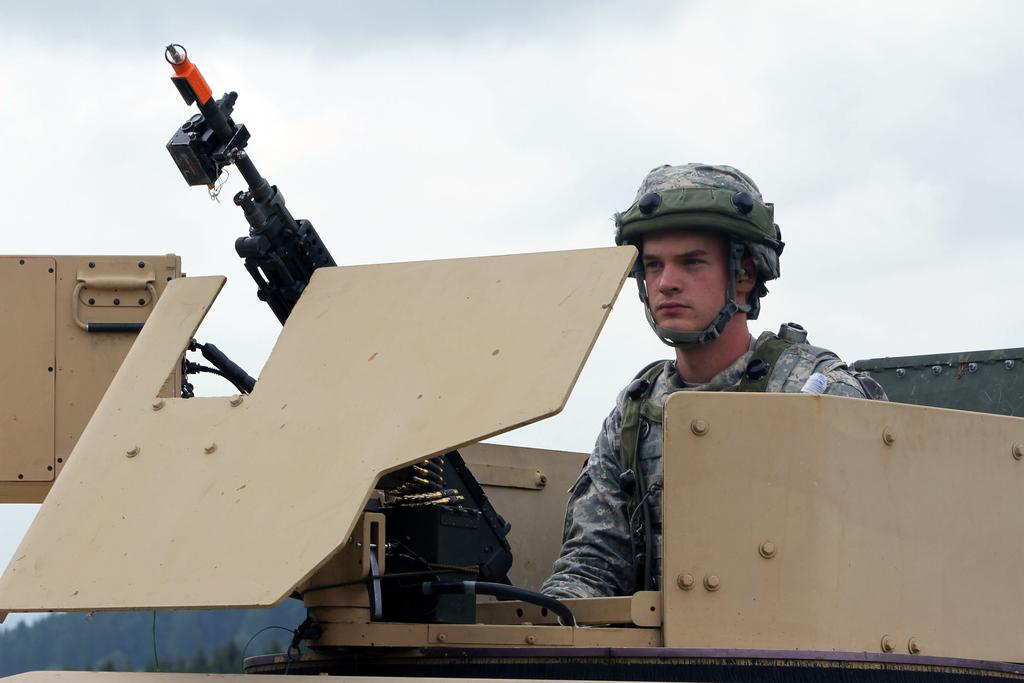What is the person standing on in the image? The person is standing on an army tank. What is the person holding in the image? The person is holding a gun. What can be seen in the background of the image? The sky is visible in the background of the image. What type of yoke is being used by the person in the image? There is no yoke present in the image; the person is holding a gun and standing on an army tank. 